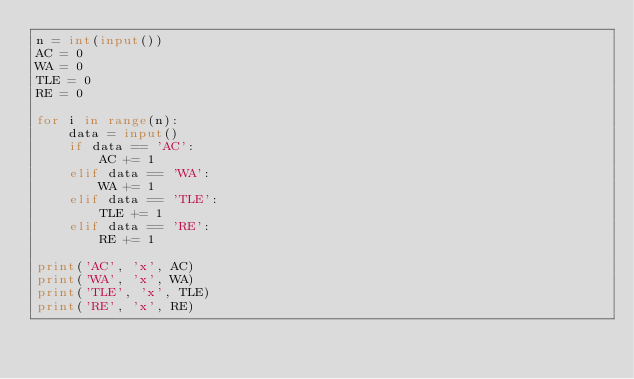<code> <loc_0><loc_0><loc_500><loc_500><_Python_>n = int(input())
AC = 0
WA = 0
TLE = 0
RE = 0

for i in range(n):
    data = input()
    if data == 'AC':
        AC += 1
    elif data == 'WA':
        WA += 1
    elif data == 'TLE':
        TLE += 1
    elif data == 'RE':
        RE += 1

print('AC', 'x', AC)
print('WA', 'x', WA)
print('TLE', 'x', TLE)
print('RE', 'x', RE)</code> 